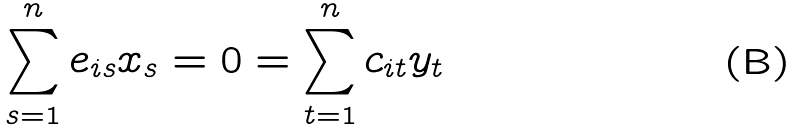Convert formula to latex. <formula><loc_0><loc_0><loc_500><loc_500>\sum _ { s = 1 } ^ { n } e _ { i s } x _ { s } = 0 = \sum _ { t = 1 } ^ { n } c _ { i t } y _ { t }</formula> 